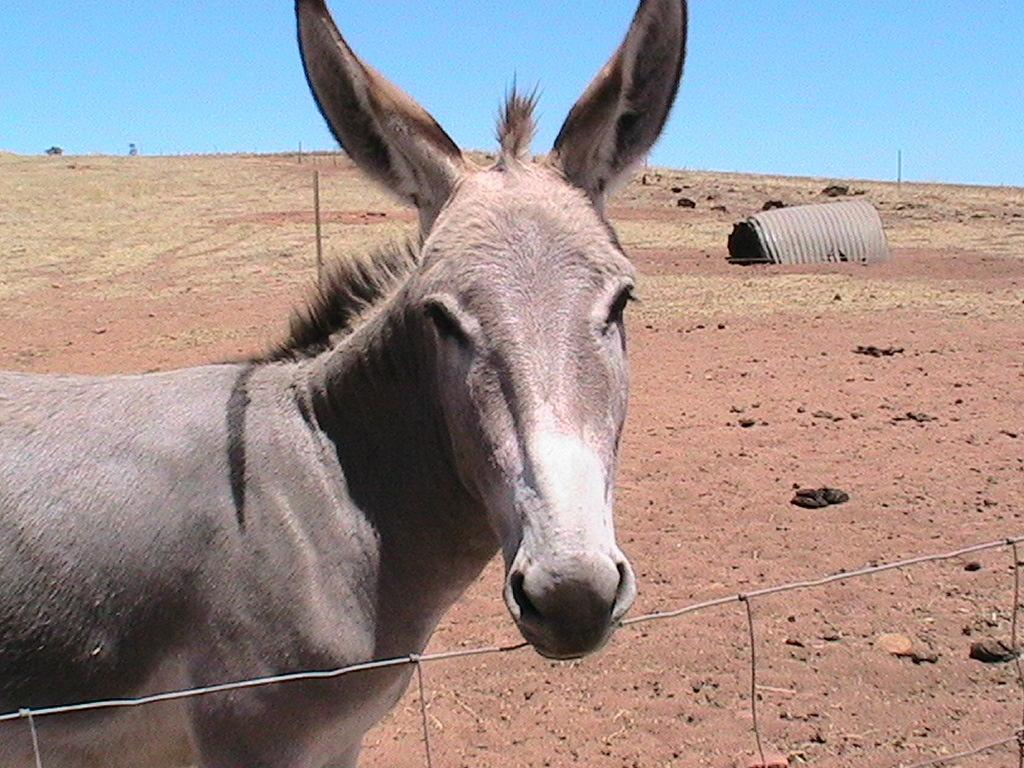What type of barrier is located at the bottom of the image? There is a wire fence at the bottom of the image. What animal is in the center of the image? There is a donkey in the center of the image. What can be seen in the background of the image? The sky is visible in the background of the image, along with poles and a few other objects. What type of breakfast is the donkey eating in the image? There is no breakfast present in the image; it features a donkey standing in the center. What part of the donkey's body is beating with love in the image? There is no heart or any indication of love present in the image; it simply shows a donkey standing. 